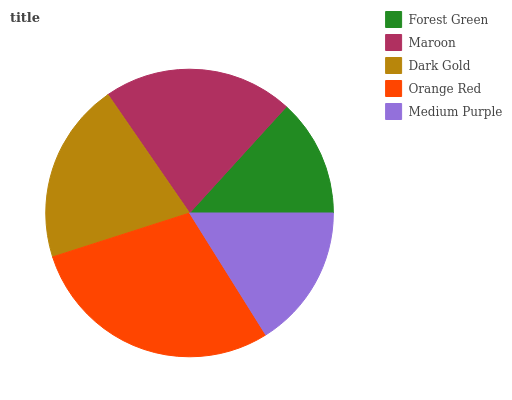Is Forest Green the minimum?
Answer yes or no. Yes. Is Orange Red the maximum?
Answer yes or no. Yes. Is Maroon the minimum?
Answer yes or no. No. Is Maroon the maximum?
Answer yes or no. No. Is Maroon greater than Forest Green?
Answer yes or no. Yes. Is Forest Green less than Maroon?
Answer yes or no. Yes. Is Forest Green greater than Maroon?
Answer yes or no. No. Is Maroon less than Forest Green?
Answer yes or no. No. Is Dark Gold the high median?
Answer yes or no. Yes. Is Dark Gold the low median?
Answer yes or no. Yes. Is Maroon the high median?
Answer yes or no. No. Is Orange Red the low median?
Answer yes or no. No. 